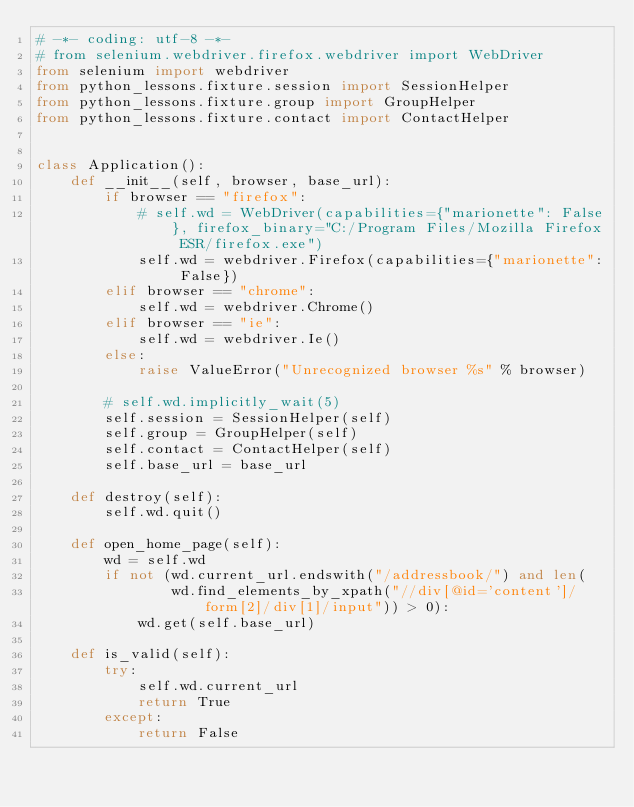Convert code to text. <code><loc_0><loc_0><loc_500><loc_500><_Python_># -*- coding: utf-8 -*-
# from selenium.webdriver.firefox.webdriver import WebDriver
from selenium import webdriver
from python_lessons.fixture.session import SessionHelper
from python_lessons.fixture.group import GroupHelper
from python_lessons.fixture.contact import ContactHelper


class Application():
    def __init__(self, browser, base_url):
        if browser == "firefox":
            # self.wd = WebDriver(capabilities={"marionette": False}, firefox_binary="C:/Program Files/Mozilla Firefox ESR/firefox.exe")
            self.wd = webdriver.Firefox(capabilities={"marionette": False})
        elif browser == "chrome":
            self.wd = webdriver.Chrome()
        elif browser == "ie":
            self.wd = webdriver.Ie()
        else:
            raise ValueError("Unrecognized browser %s" % browser)

        # self.wd.implicitly_wait(5)
        self.session = SessionHelper(self)
        self.group = GroupHelper(self)
        self.contact = ContactHelper(self)
        self.base_url = base_url

    def destroy(self):
        self.wd.quit()

    def open_home_page(self):
        wd = self.wd
        if not (wd.current_url.endswith("/addressbook/") and len(
                wd.find_elements_by_xpath("//div[@id='content']/form[2]/div[1]/input")) > 0):
            wd.get(self.base_url)

    def is_valid(self):
        try:
            self.wd.current_url
            return True
        except:
            return False
</code> 